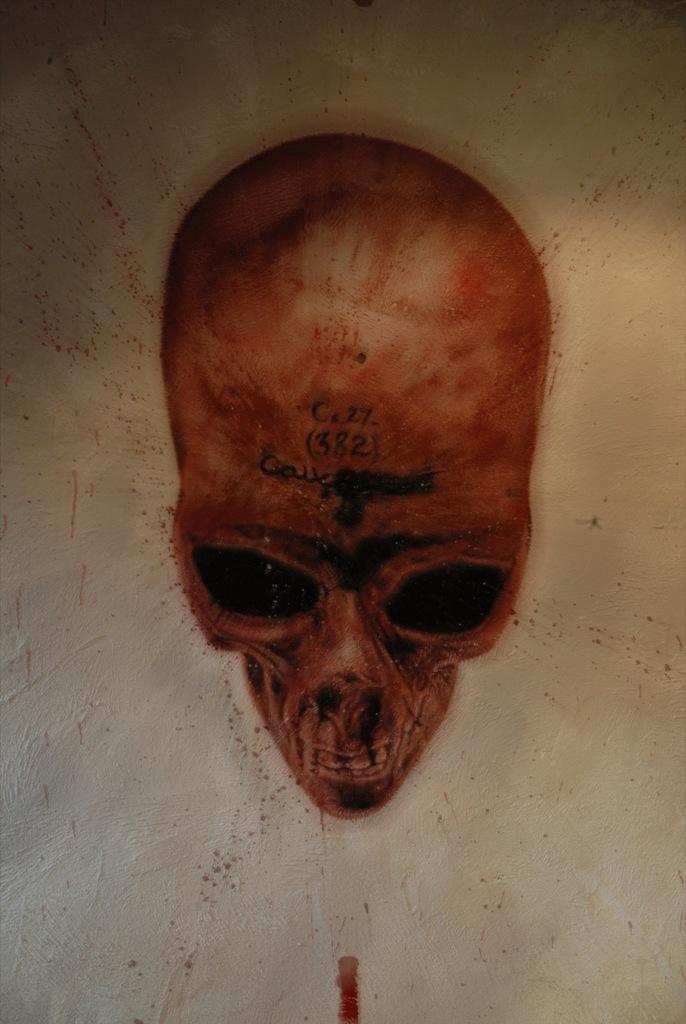How would you summarize this image in a sentence or two? In this image I can see in the middle it looks like a painting of a skull. 